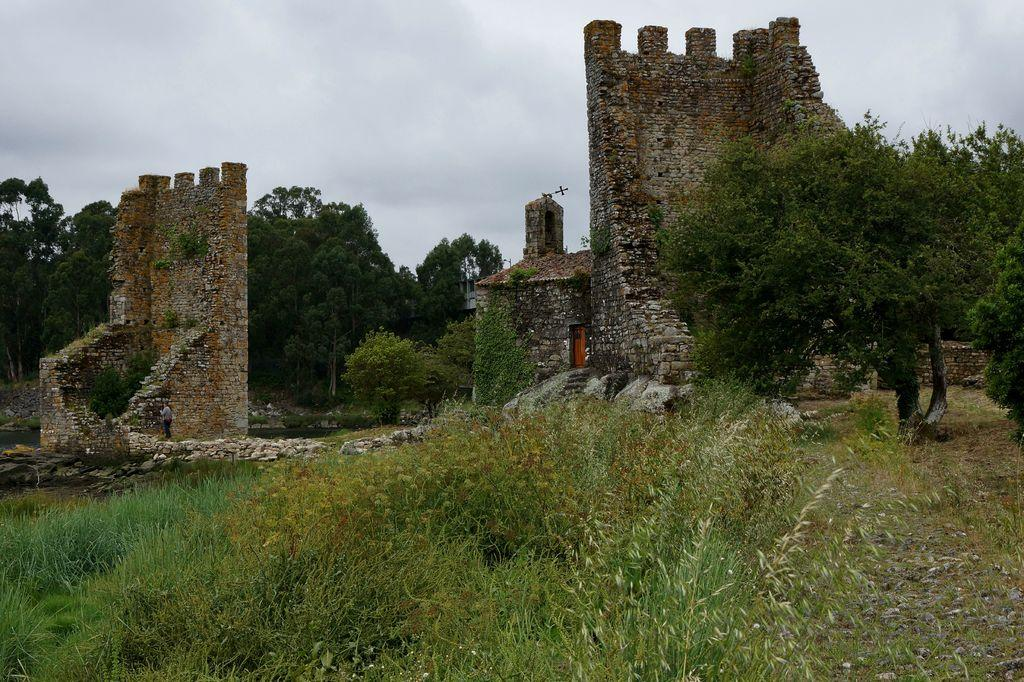What is the main subject of the image? The main subject of the image is a collapsed fort. What can be seen around the fort? There are trees and grass around the fort. Is there anyone present in the image? Yes, there is a person standing on the left side in front of the fort wall. What type of potato can be seen growing near the collapsed fort? There is no potato present in the image; the image only shows a collapsed fort, trees, grass, and a person. 